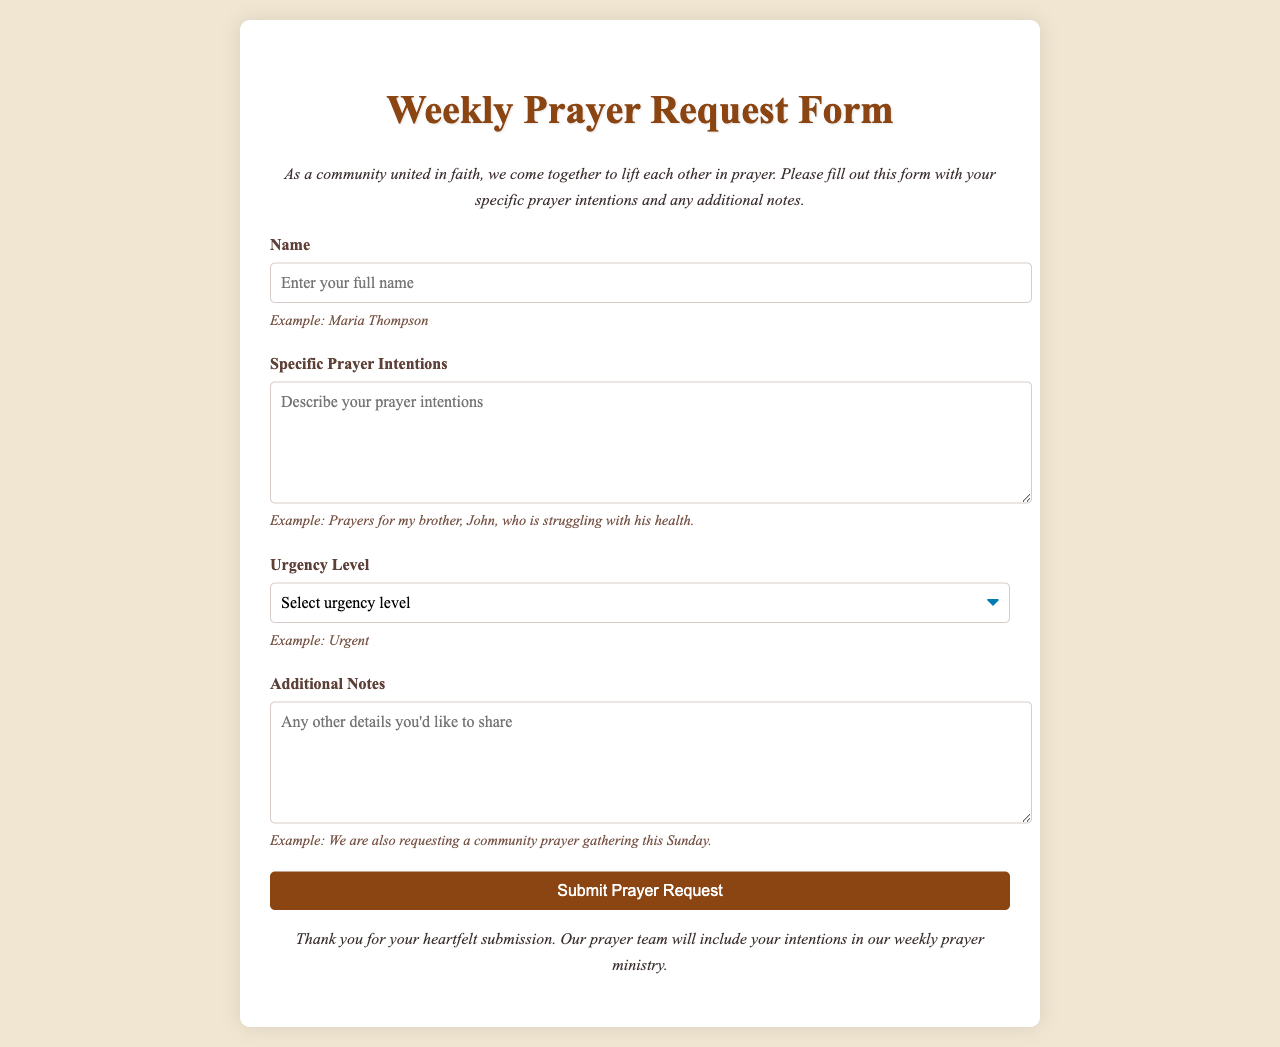what is the title of the document? The title is prominently displayed at the top of the form.
Answer: Weekly Prayer Request Form who should fill out this form? The form is intended for community members who wish to submit prayer intentions.
Answer: Community members what is the urgency level for the prayer request? The document asks for an urgency level to be indicated, providing specific options.
Answer: Urgent, High, Medium, Low how many prayer intentions can be shared? The form allows for a detailed description of prayer intentions in a designated area.
Answer: Any number of intentions what is the purpose of the additional notes section? This section allows the requester to include any other relevant information.
Answer: To provide extra details what is the example provided for the name field? The form includes an example to guide users in filling the name section.
Answer: Maria Thompson what is indicated as the closing statement? The closing statement expresses gratitude for the submission.
Answer: Thank you for your heartfelt submission what type of input is required for 'Specific Prayer Intentions'? The form specifies the need for a detailed written input for this section.
Answer: Text input what is the styling of the submit button? The button is designed to stand out with specific colors and styles.
Answer: Brown background with white text 